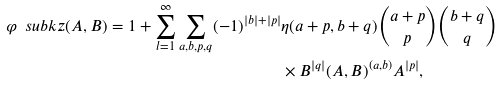Convert formula to latex. <formula><loc_0><loc_0><loc_500><loc_500>\varphi \ s u b k z ( A , B ) = 1 + \sum _ { l = 1 } ^ { \infty } \sum _ { a , b , p , q } ( - 1 ) ^ { | b | + | p | } & \eta ( a + p , b + q ) \binom { a + p } { p } \binom { b + q } { q } \\ & \times B ^ { | q | } ( A , B ) ^ { ( a , b ) } A ^ { | p | } ,</formula> 